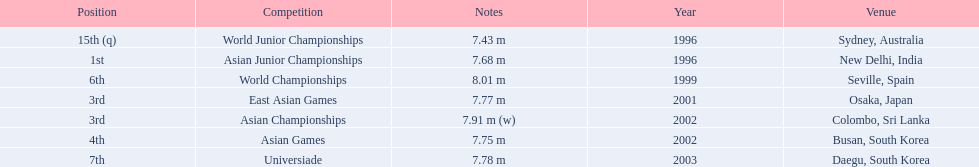What jumps did huang le make in 2002? 7.91 m (w), 7.75 m. Which jump was the longest? 7.91 m (w). 